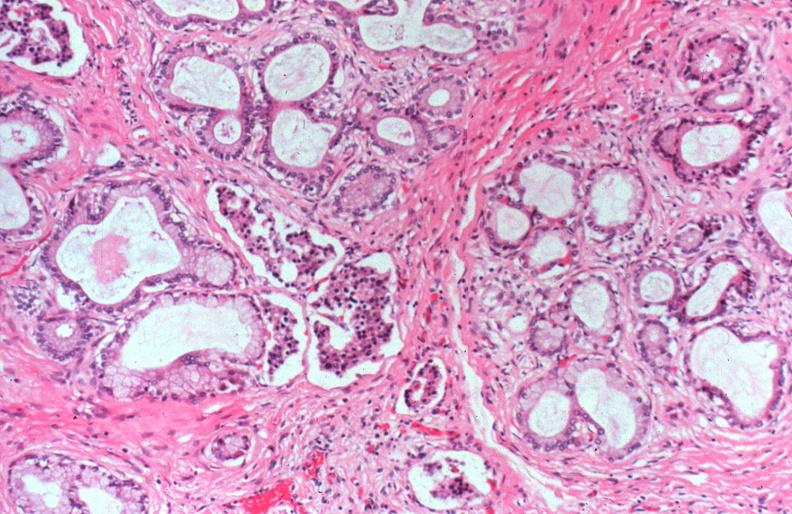does this image show cystic fibrosis?
Answer the question using a single word or phrase. Yes 